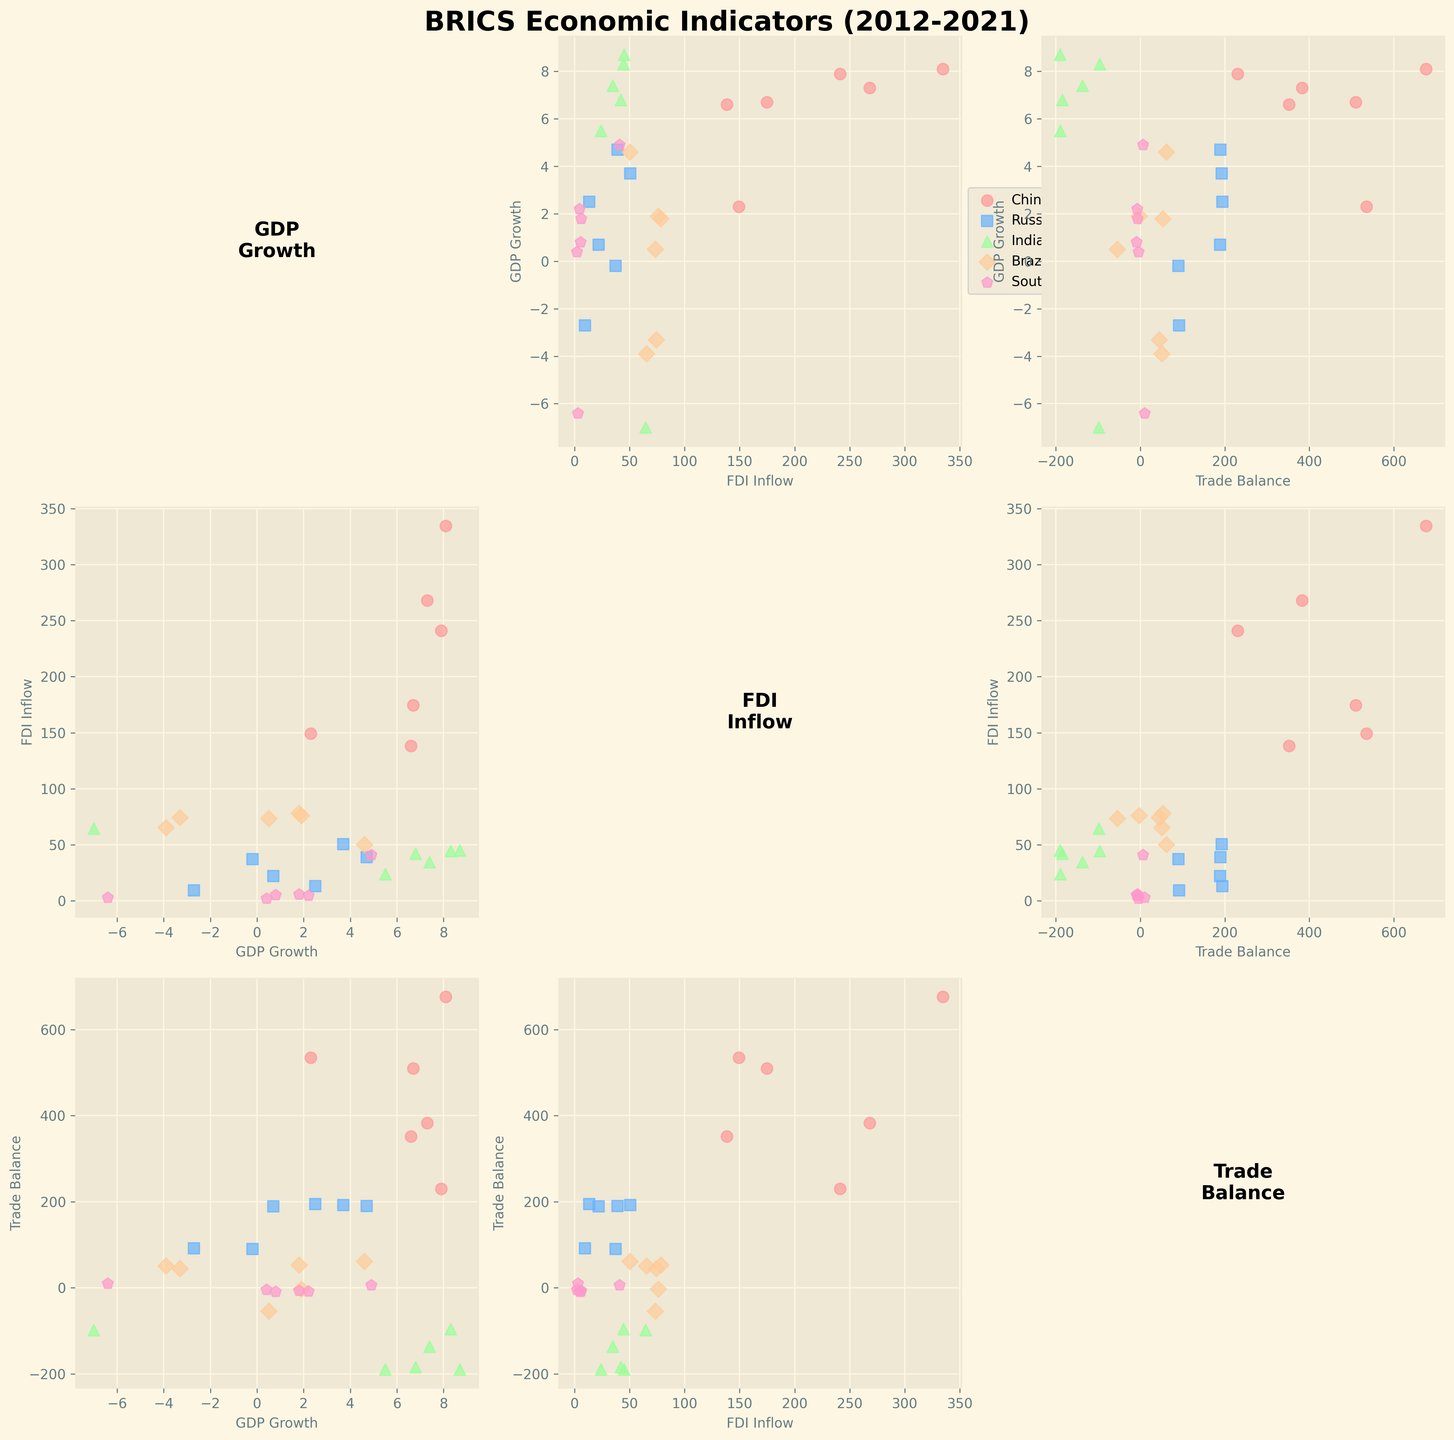What's the title of the figure? The title is usually placed at the top of the figure, and in this case, it reads "BRICS Economic Indicators (2012-2021)". This indicates that the figure presents economic indicators for BRICS countries from 2012 to 2021.
Answer: BRICS Economic Indicators (2012-2021) What do the x-axis and y-axis represent generally in the scatter plots? The scatterplot matrix comprises multiple scatter plots with different economic variables on the x and y axes. Each x-axis and y-axis can represent either GDP Growth, FDI Inflow, or Trade Balance. These labels are indicated on each scatter plot's axes.
Answer: GDP Growth, FDI Inflow, Trade Balance How is the economic performance of Russia compared to India in terms of GDP Growth over the years? To assess the economic performance, look at the scatter plot where GDP Growth is on the y-axis and track the points representing Russia and India over the years. Russia's GDP Growth points are generally lower than India's, especially considering Russia's negative values in 2016 and 2020 while India shows higher positive growth in most years.
Answer: India generally performs better Which country shows the highest GDP Growth in the dataset? Check the scatter plot with GDP Growth on the y-axis and look for the highest plotted point. The highest GDP Growth is an 8.7% increase by India in 2021.
Answer: India Is there a country with consistent Trade Balance surplus over the years? Examine the scatter plots where Trade Balance is one of the axes and trace each country’s data points across the years. China consistently shows positive Trade Balance values, indicating a trade surplus.
Answer: China What trend can be observed between GDP Growth and Trade Balance in China? Observe the scatter plot with GDP Growth on the y-axis and Trade Balance on the x-axis for China's data points. Generally, as China's Trade Balance increases, its GDP Growth first increases and then slightly declines, showing an overall positive correlation with fluctuations.
Answer: Positive correlation with fluctuations Is there any year where all BRICS nations had positive GDP Growth? Look at the scatter plots with GDP Growth on the y-axis and the data points for all countries. In 2012, 2014, 2018, and 2021, all BRICS nations had positive GDP Growth values.
Answer: 2012, 2014, 2018, 2021 How does Brazil’s FDI Inflow compare to South Africa’s in 2021? Locate the scatter plot for 2021 data and compare the points for Brazil and South Africa on the axis representing FDI Inflow. Brazil’s FDI Inflow in 2021 is significantly higher, with approximately 50.4 compared to South Africa’s 40.9.
Answer: Brazil higher Which two economic indicators show the strongest correlation for India? Look at India’s data points across different scatterplots representing GDP Growth, FDI Inflow, and Trade Balance. The scatter plot with GDP Growth on y-axis and FDI Inflow on x-axis indicates a relatively strong positive relationship as both increase over several years.
Answer: GDP Growth & FDI Inflow What can be inferred about Russia’s Trade Balance in 2016 compared to 2021? Check the points representing Trade Balance for Russia in the respective years by looking at the specific scatter plots. In 2016, Russia had a Trade Balance of 90.3, which slightly increased to 189.8 by 2021, indicating an improvement.
Answer: Improvement 